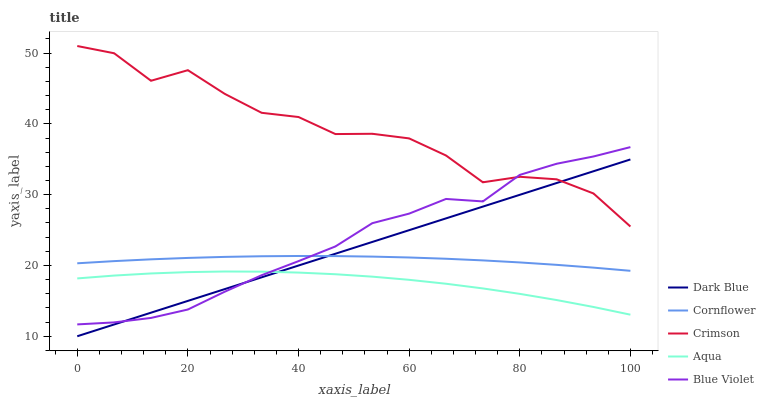Does Dark Blue have the minimum area under the curve?
Answer yes or no. No. Does Dark Blue have the maximum area under the curve?
Answer yes or no. No. Is Aqua the smoothest?
Answer yes or no. No. Is Aqua the roughest?
Answer yes or no. No. Does Aqua have the lowest value?
Answer yes or no. No. Does Dark Blue have the highest value?
Answer yes or no. No. Is Cornflower less than Crimson?
Answer yes or no. Yes. Is Crimson greater than Cornflower?
Answer yes or no. Yes. Does Cornflower intersect Crimson?
Answer yes or no. No. 